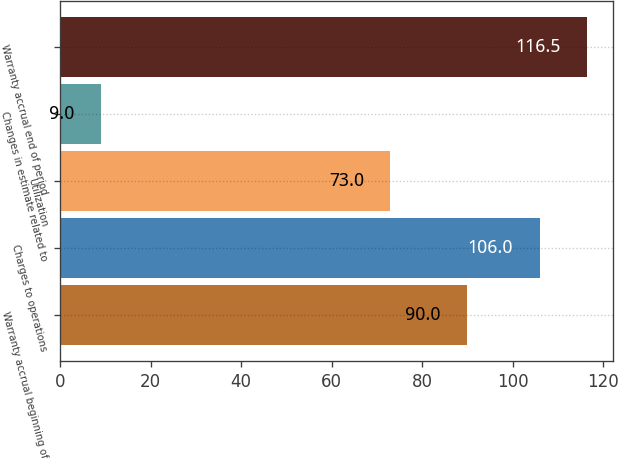Convert chart to OTSL. <chart><loc_0><loc_0><loc_500><loc_500><bar_chart><fcel>Warranty accrual beginning of<fcel>Charges to operations<fcel>Utilization<fcel>Changes in estimate related to<fcel>Warranty accrual end of period<nl><fcel>90<fcel>106<fcel>73<fcel>9<fcel>116.5<nl></chart> 